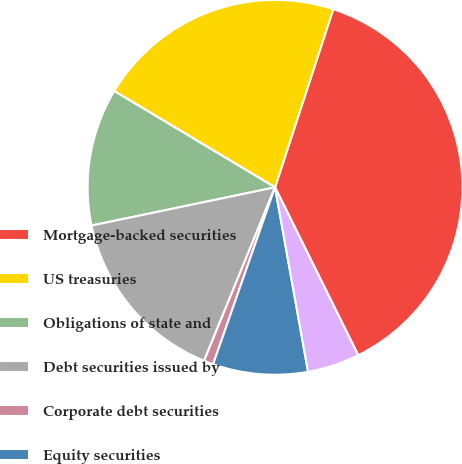Convert chart to OTSL. <chart><loc_0><loc_0><loc_500><loc_500><pie_chart><fcel>Mortgage-backed securities<fcel>US treasuries<fcel>Obligations of state and<fcel>Debt securities issued by<fcel>Corporate debt securities<fcel>Equity securities<fcel>Other primarily asset-backed<nl><fcel>37.65%<fcel>21.44%<fcel>11.86%<fcel>15.55%<fcel>0.82%<fcel>8.18%<fcel>4.5%<nl></chart> 